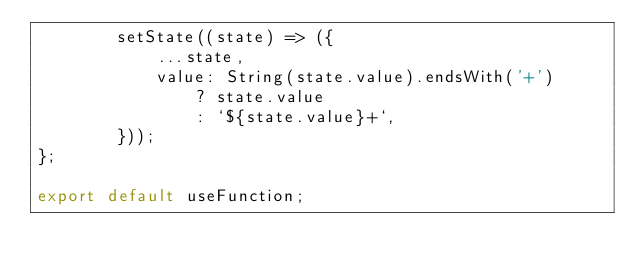Convert code to text. <code><loc_0><loc_0><loc_500><loc_500><_JavaScript_>		setState((state) => ({
			...state,
			value: String(state.value).endsWith('+')
				? state.value
				: `${state.value}+`,
		}));
};

export default useFunction;
</code> 